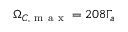<formula> <loc_0><loc_0><loc_500><loc_500>\Omega _ { C , m a x } = 2 0 8 \Gamma _ { a }</formula> 